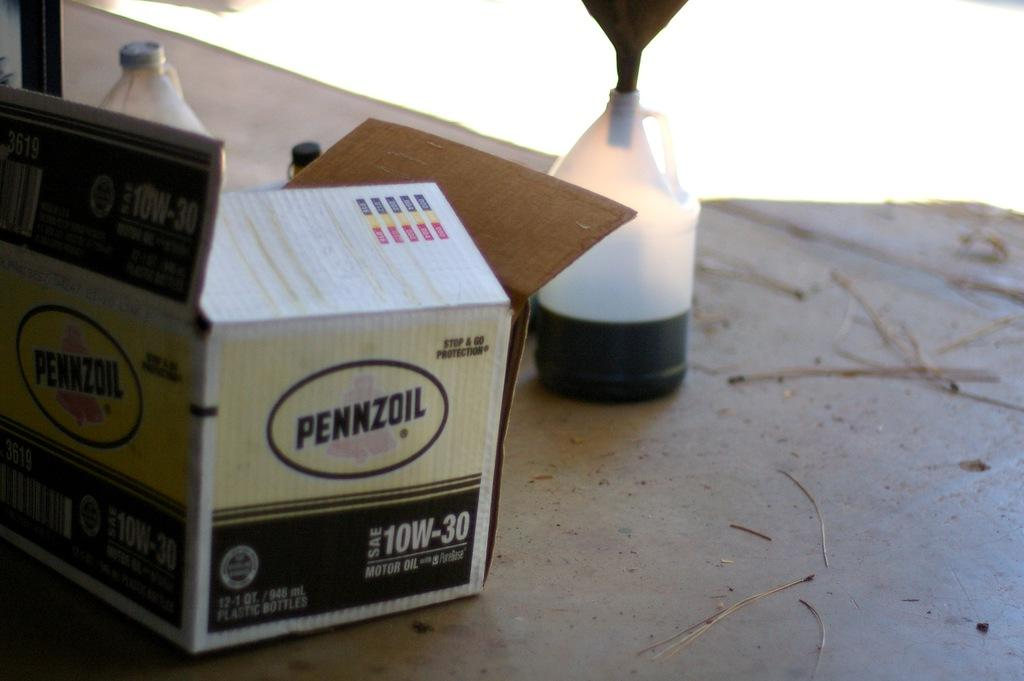Provide a one-sentence caption for the provided image. An open yellow and black box of Pennzoil. 